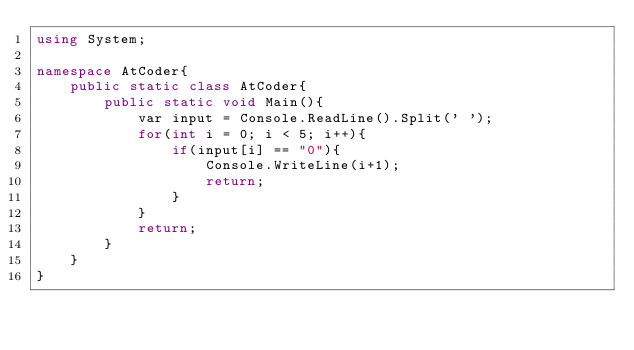<code> <loc_0><loc_0><loc_500><loc_500><_C#_>using System;

namespace AtCoder{
    public static class AtCoder{
        public static void Main(){
            var input = Console.ReadLine().Split(' ');
            for(int i = 0; i < 5; i++){
                if(input[i] == "0"){
                    Console.WriteLine(i+1);
                    return;
                }
            }
            return;
        }
    }
}</code> 